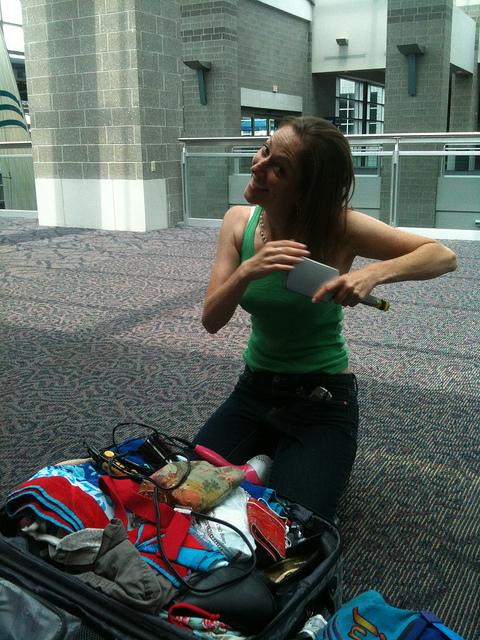What is in the girls pocket?
Keep it brief. Cell phone. What is she doing to her hair?
Be succinct. Brushing. What is in front of the girl?
Concise answer only. Suitcase. 